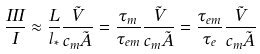<formula> <loc_0><loc_0><loc_500><loc_500>\frac { I I I } { I } \approx \frac { L } { l _ { * } } \frac { \tilde { V } } { c _ { m } \tilde { A } } = \frac { \tau _ { m } } { \tau _ { e m } } \frac { \tilde { V } } { c _ { m } \tilde { A } } = \frac { \tau _ { e m } } { \tau _ { e } } \frac { \tilde { V } } { c _ { m } \tilde { A } }</formula> 